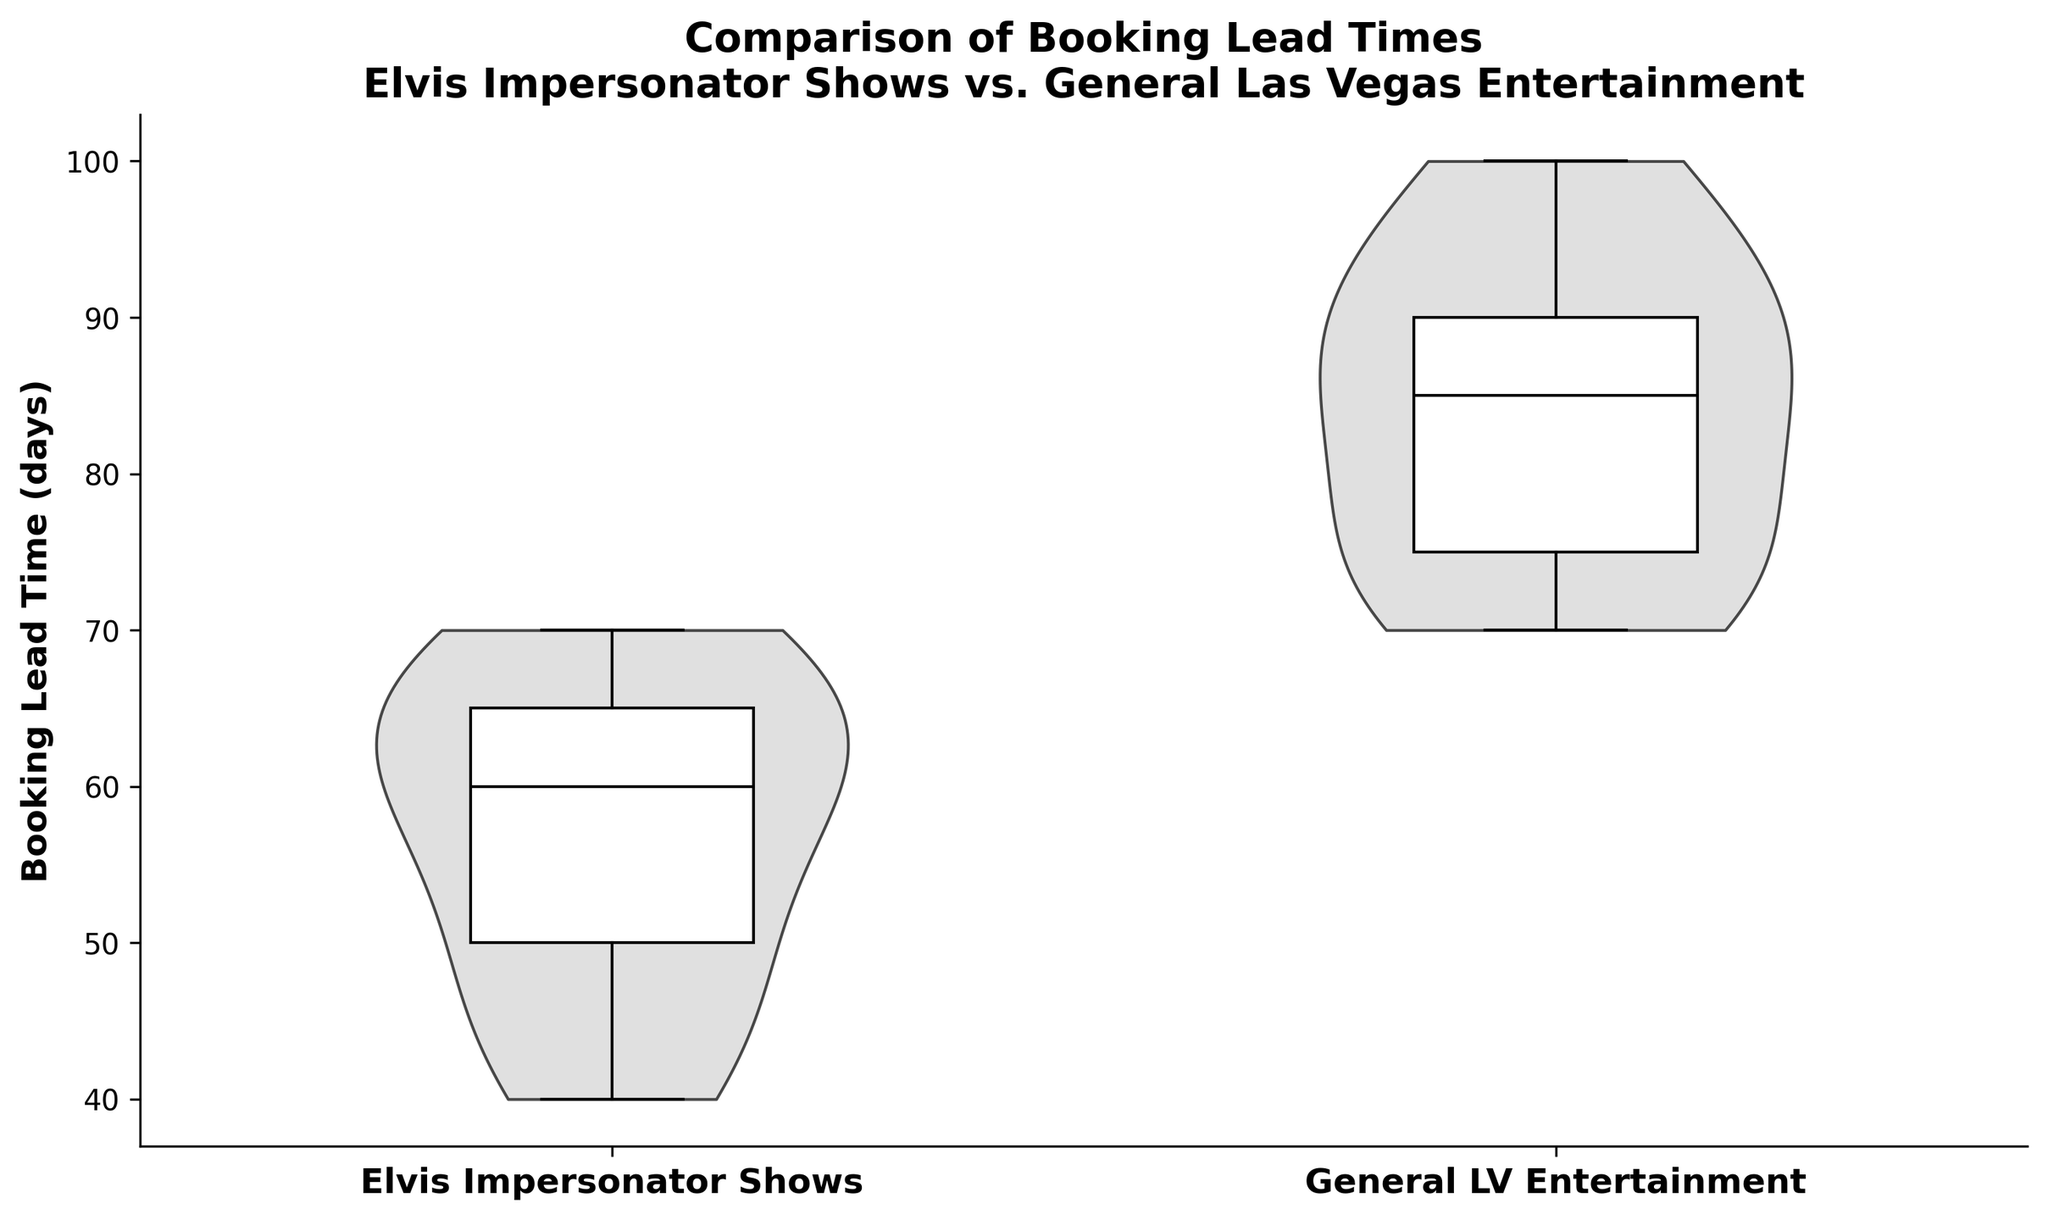What is the title of the figure? The title is located at the top of the figure and summarizes the content of the chart.
Answer: Comparison of Booking Lead Times Elvis Impersonator Shows vs. General Las Vegas Entertainment What does the x-axis represent? The x-axis labels below the violin plots describe the categories being compared in the chart.
Answer: Elvis Impersonator Shows and General LV Entertainment What is the range of booking lead times depicted on the y-axis? The y-axis on the left side of the chart indicates booking lead times in days, with tick marks showing the range.
Answer: Approximately 30 to 110 days Which category has the highest median booking lead time? The box plots within the violin plots show the median as a line; the category with a higher median line is the answer.
Answer: General LV Entertainment What is the distribution shape for Elvis impersonator shows compared to general Las Vegas entertainment? Examine the shape of the violin plots; Elvis shows might have a symmetrical shape, while general entertainment might have a more spread or skewed shape.
Answer: Elvis shows have a more symmetrical distribution, while general entertainment is more spread out Are there any outliers in either category? Outliers would be points outside the whiskers of the box plots within the violin plots.
Answer: No Which category appears to have more variability in booking lead times? Variability can be seen by comparing the spread (width and height) of the violin plots and the range of the box plots.
Answer: General LV Entertainment What is the interquartile range (IQR) for booking lead times in general Las Vegas entertainment? The IQR is the range between the 25th to 75th percentile, shown by the box's width in the box plot. Measure this visually on the y-axis.
Answer: Approximately 20 days (from about 82 to 102 days) How does the peak density compare between the two categories? The peak density can be identified by looking at the widest part of the violin plot for each category.
Answer: General LV Entertainment has a higher peak density What is the approximate booking lead time for the peak density of Elvis impersonator shows? The peak density for the Elvis shows can be found at the widest part of its violin plot, and the y-axis value at this point indicates the peak booking lead time.
Answer: Around 55-65 days 